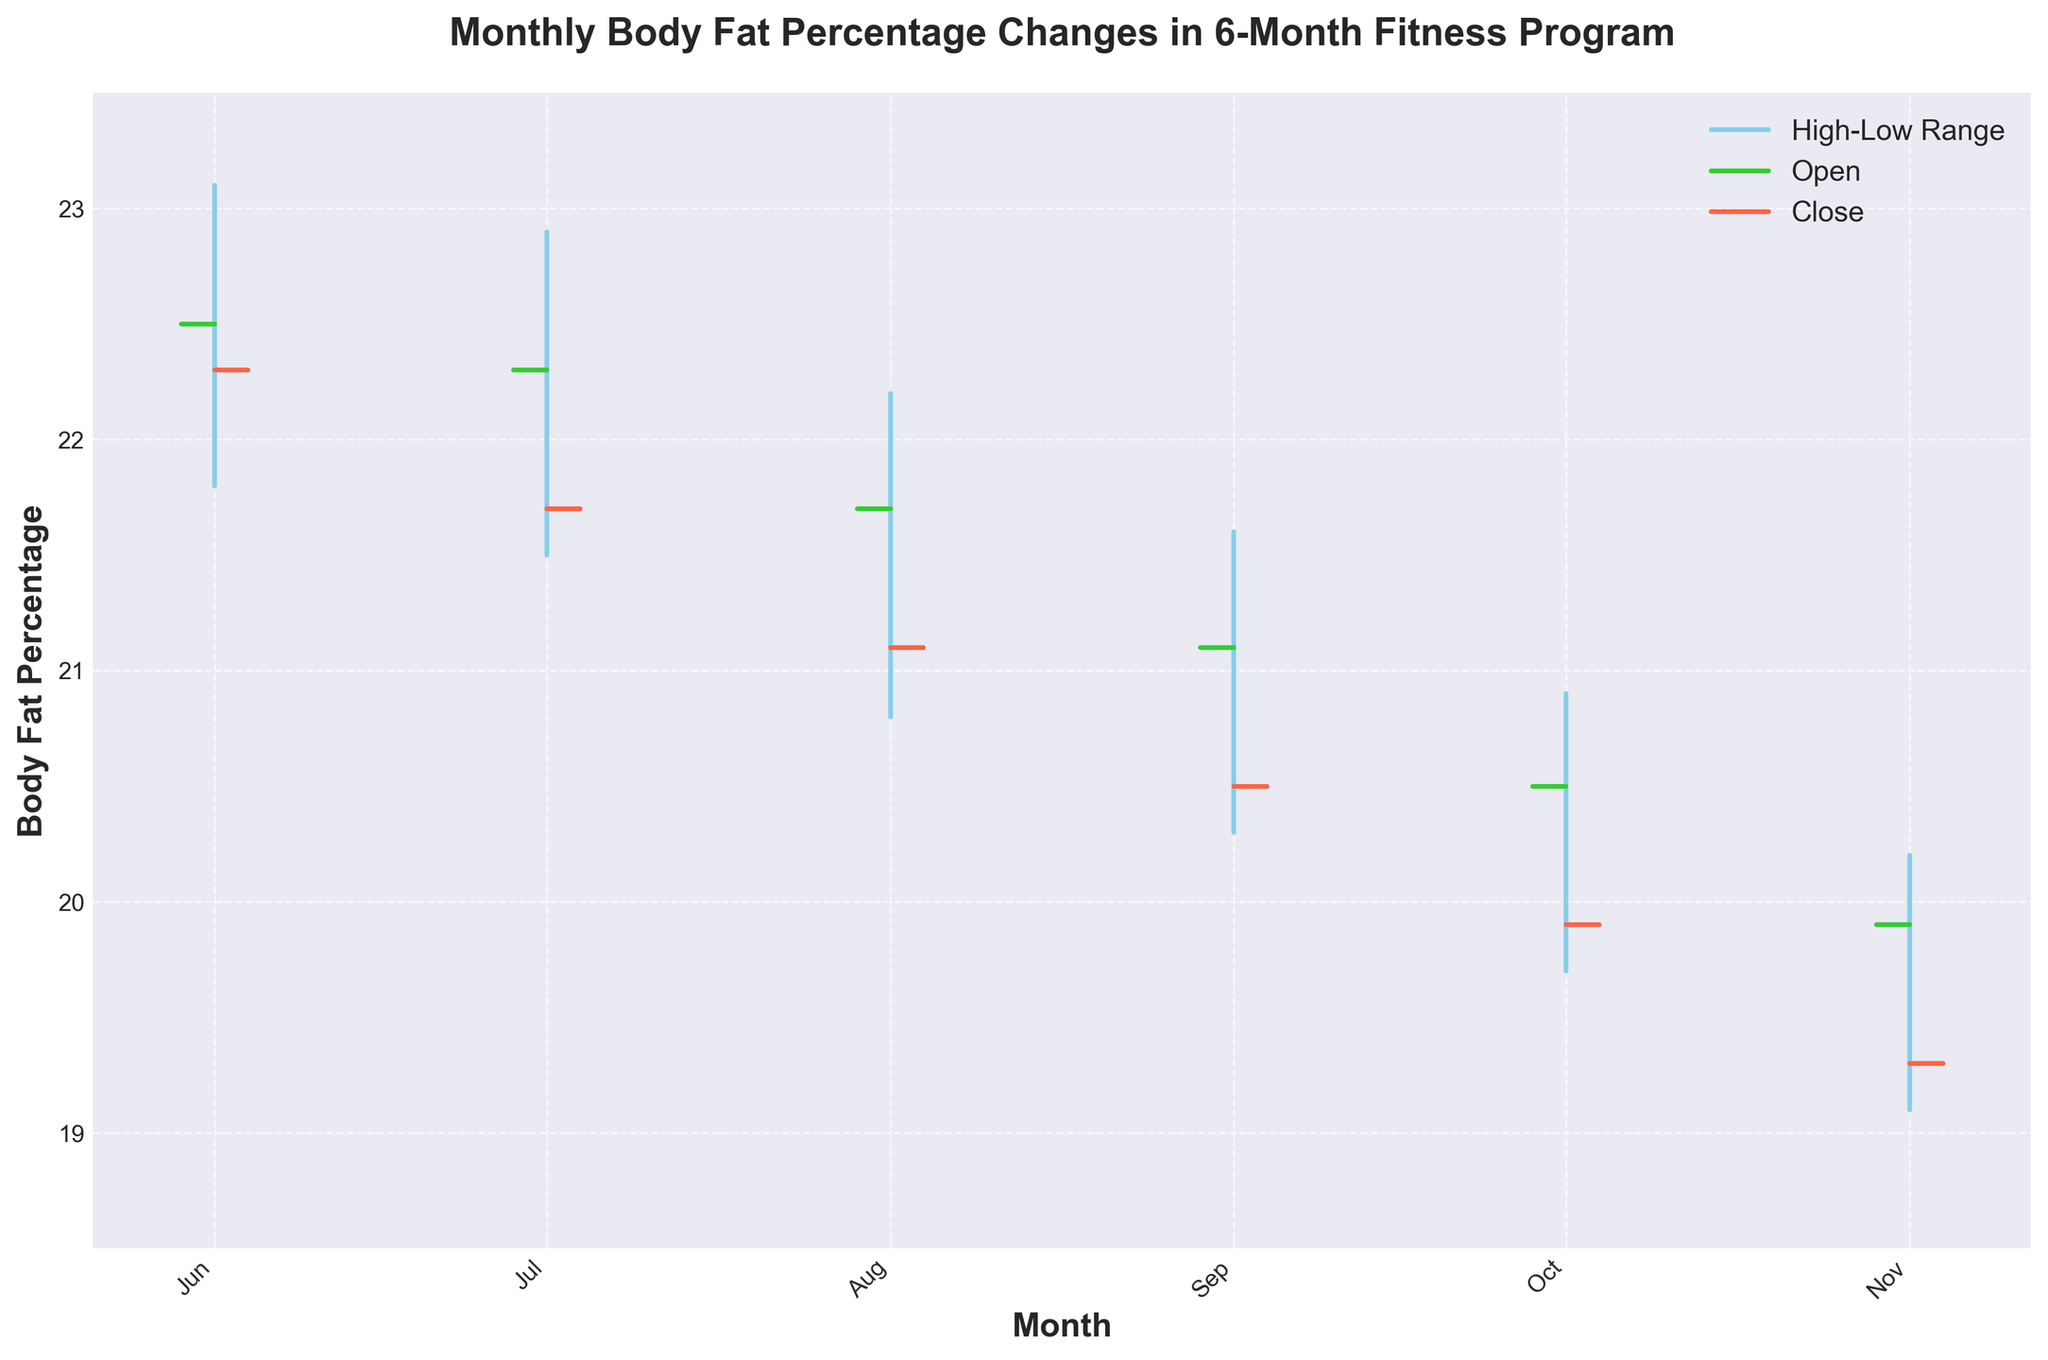What's the title of the chart? The title is prominently displayed at the top of the chart.
Answer: Monthly Body Fat Percentage Changes in 6-Month Fitness Program What month shows the highest body fat percentage? By looking at the "High" values on the chart, June shows the highest "High" value at 23.1%.
Answer: June In which month did the body fat percentage close at the lowest value? The "Close" values for each month can be checked. November has the lowest "Close" value at 19.3%.
Answer: November Which month had the greatest decrease in body fat percentage from open to close? You need to calculate the difference between the open and close values for each month and find the greatest difference: June (22.5 - 22.3 = 0.2), July (22.3 - 21.7 = 0.6), August (21.7 - 21.1 = 0.6), September (21.1 - 20.5 = 0.6), October (20.5 - 19.9 = 0.6), November (19.9 - 19.3 = 0.6). All months except June have a decrease of 0.6%.
Answer: July, August, September, October, November Which month shows the smallest range between the highest and lowest body fat percentage? Calculate the difference between the high and low values for each month: June (23.1 - 21.8 = 1.3), July (22.9 - 21.5 = 1.4), August (22.2 - 20.8 = 1.4), September (21.6 - 20.3 = 1.3), October (20.9 - 19.7 = 1.2), November (20.2 - 19.1 = 1.1). The smallest range is in November.
Answer: November How many ticks are used to represent the closing values on the chart? Each month has one closing value represented by a tick on the chart. There are 6 data points for 6 months.
Answer: 6 Which month saw the largest increase in body fat percentage within the month? Calculate the difference between the high and low values to determine the increase within each month: June (23.1 - 21.8 = 1.3), July (22.9 - 21.5 = 1.4), August (22.2 - 20.8 = 1.4), September (21.6 - 20.3 = 1.3), October (20.9 - 19.7 = 1.2), November (20.2 - 19.1 = 1.1). The largest increase is in July and August (both 1.4%).
Answer: July, August What is the trend in body fat percentage over the 6-month period? Observing the close values over time: June (22.3), July (21.7), August (21.1), September (20.5), October (19.9), November (19.3). The trend indicates a consistent decrease in body fat percentage.
Answer: Decreasing Which month experienced a close value that was lower than both its open and high values? Check each month's close value against its open and high values: June (22.3 < 22.5, < 23.1), July (21.7 < 22.3, < 22.9), August (21.1 < 21.7, < 22.2), September (20.5 < 21.1, < 21.6), October (19.9 < 20.5, < 20.9), November (19.3 < 19.9, < 20.2). All months meet this criterion.
Answer: June, July, August, September, October, November 